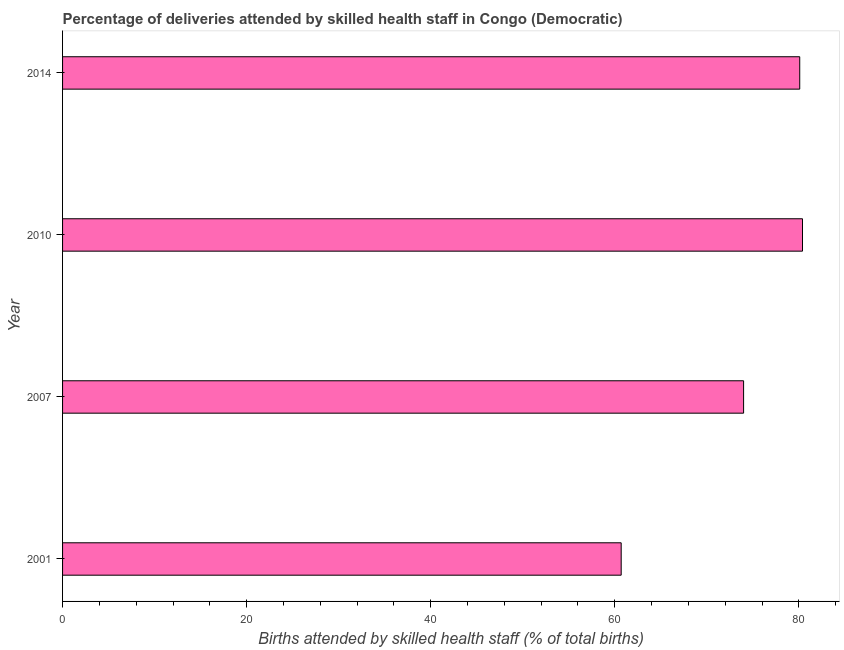What is the title of the graph?
Your answer should be compact. Percentage of deliveries attended by skilled health staff in Congo (Democratic). What is the label or title of the X-axis?
Offer a very short reply. Births attended by skilled health staff (% of total births). What is the label or title of the Y-axis?
Keep it short and to the point. Year. What is the number of births attended by skilled health staff in 2007?
Provide a short and direct response. 74. Across all years, what is the maximum number of births attended by skilled health staff?
Ensure brevity in your answer.  80.4. Across all years, what is the minimum number of births attended by skilled health staff?
Your answer should be compact. 60.7. In which year was the number of births attended by skilled health staff minimum?
Ensure brevity in your answer.  2001. What is the sum of the number of births attended by skilled health staff?
Offer a terse response. 295.2. What is the difference between the number of births attended by skilled health staff in 2007 and 2014?
Offer a very short reply. -6.1. What is the average number of births attended by skilled health staff per year?
Your answer should be compact. 73.8. What is the median number of births attended by skilled health staff?
Keep it short and to the point. 77.05. Is the number of births attended by skilled health staff in 2010 less than that in 2014?
Your answer should be very brief. No. Is the difference between the number of births attended by skilled health staff in 2007 and 2010 greater than the difference between any two years?
Provide a succinct answer. No. Is the sum of the number of births attended by skilled health staff in 2007 and 2014 greater than the maximum number of births attended by skilled health staff across all years?
Offer a terse response. Yes. What is the difference between the highest and the lowest number of births attended by skilled health staff?
Your answer should be very brief. 19.7. How many bars are there?
Keep it short and to the point. 4. What is the difference between two consecutive major ticks on the X-axis?
Offer a very short reply. 20. What is the Births attended by skilled health staff (% of total births) of 2001?
Give a very brief answer. 60.7. What is the Births attended by skilled health staff (% of total births) in 2007?
Keep it short and to the point. 74. What is the Births attended by skilled health staff (% of total births) of 2010?
Provide a short and direct response. 80.4. What is the Births attended by skilled health staff (% of total births) in 2014?
Keep it short and to the point. 80.1. What is the difference between the Births attended by skilled health staff (% of total births) in 2001 and 2007?
Provide a succinct answer. -13.3. What is the difference between the Births attended by skilled health staff (% of total births) in 2001 and 2010?
Keep it short and to the point. -19.7. What is the difference between the Births attended by skilled health staff (% of total births) in 2001 and 2014?
Give a very brief answer. -19.4. What is the difference between the Births attended by skilled health staff (% of total births) in 2007 and 2010?
Provide a succinct answer. -6.4. What is the ratio of the Births attended by skilled health staff (% of total births) in 2001 to that in 2007?
Keep it short and to the point. 0.82. What is the ratio of the Births attended by skilled health staff (% of total births) in 2001 to that in 2010?
Your response must be concise. 0.76. What is the ratio of the Births attended by skilled health staff (% of total births) in 2001 to that in 2014?
Keep it short and to the point. 0.76. What is the ratio of the Births attended by skilled health staff (% of total births) in 2007 to that in 2014?
Your answer should be very brief. 0.92. 